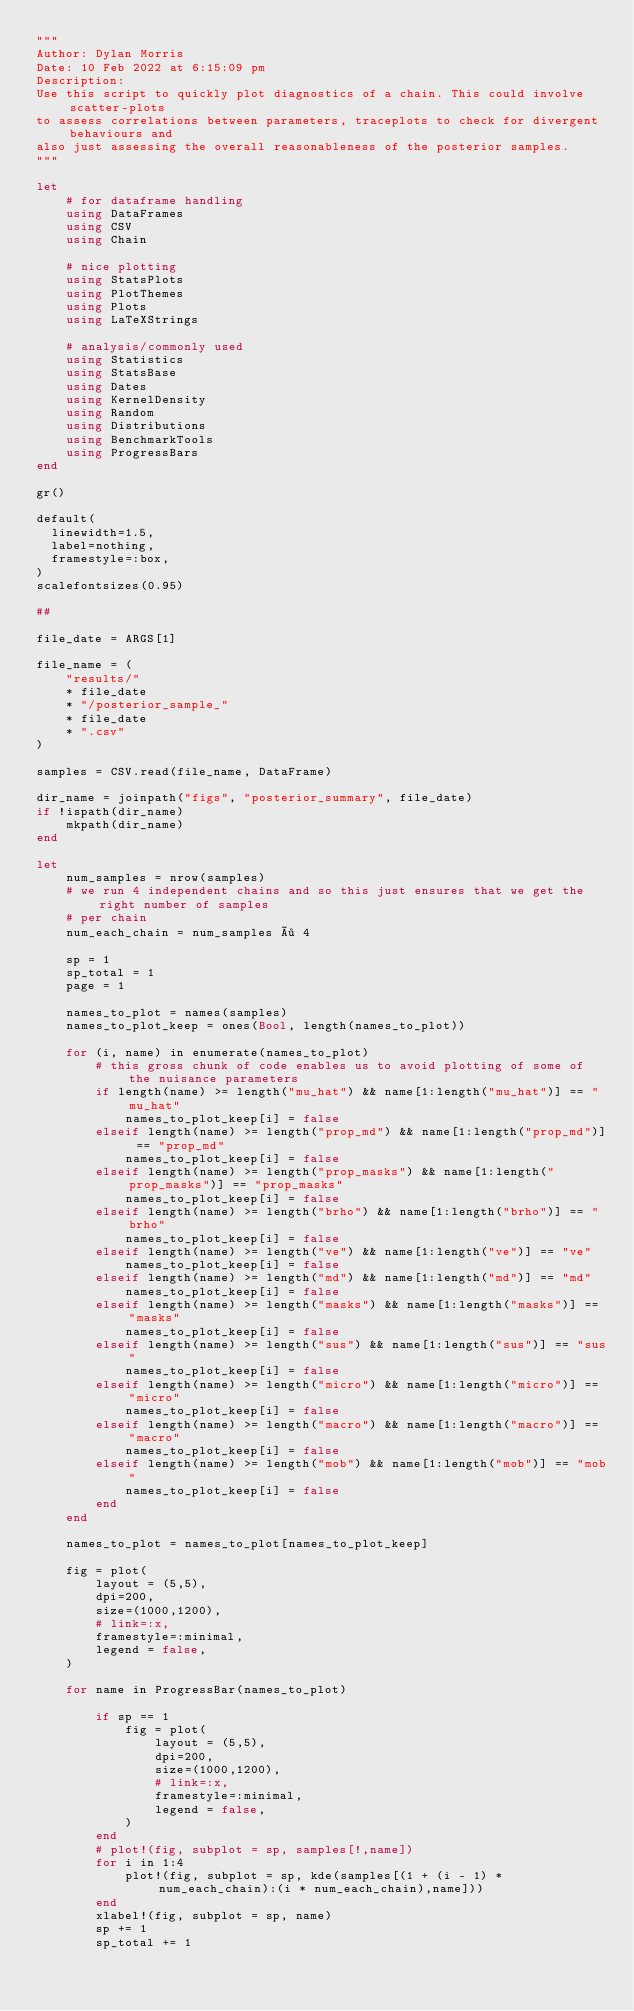Convert code to text. <code><loc_0><loc_0><loc_500><loc_500><_Julia_>"""
Author: Dylan Morris
Date: 10 Feb 2022 at 6:15:09 pm
Description: 
Use this script to quickly plot diagnostics of a chain. This could involve scatter-plots 
to assess correlations between parameters, traceplots to check for divergent behaviours and
also just assessing the overall reasonableness of the posterior samples. 
"""

let
    # for dataframe handling 
    using DataFrames
    using CSV
    using Chain

    # nice plotting 
    using StatsPlots
    using PlotThemes
    using Plots
    using LaTeXStrings

    # analysis/commonly used
    using Statistics
    using StatsBase 
    using Dates
    using KernelDensity
    using Random
    using Distributions
    using BenchmarkTools
    using ProgressBars
end

gr()

default(
	linewidth=1.5, 
	label=nothing, 
	framestyle=:box,
)
scalefontsizes(0.95)

##

file_date = ARGS[1]

file_name = (
    "results/"
    * file_date 
    * "/posterior_sample_"
    * file_date 
    * ".csv"
)

samples = CSV.read(file_name, DataFrame)

dir_name = joinpath("figs", "posterior_summary", file_date)
if !ispath(dir_name)
    mkpath(dir_name)
end

let
    num_samples = nrow(samples)
    # we run 4 independent chains and so this just ensures that we get the right number of samples 
    # per chain 
    num_each_chain = num_samples ÷ 4
    
    sp = 1
    sp_total = 1
    page = 1

    names_to_plot = names(samples)
    names_to_plot_keep = ones(Bool, length(names_to_plot))
    
    for (i, name) in enumerate(names_to_plot)
        # this gross chunk of code enables us to avoid plotting of some of the nuisance parameters
        if length(name) >= length("mu_hat") && name[1:length("mu_hat")] == "mu_hat" 
            names_to_plot_keep[i] = false
        elseif length(name) >= length("prop_md") && name[1:length("prop_md")] == "prop_md"
            names_to_plot_keep[i] = false
        elseif length(name) >= length("prop_masks") && name[1:length("prop_masks")] == "prop_masks"
            names_to_plot_keep[i] = false
        elseif length(name) >= length("brho") && name[1:length("brho")] == "brho"
            names_to_plot_keep[i] = false
        elseif length(name) >= length("ve") && name[1:length("ve")] == "ve"
            names_to_plot_keep[i] = false
        elseif length(name) >= length("md") && name[1:length("md")] == "md"
            names_to_plot_keep[i] = false
        elseif length(name) >= length("masks") && name[1:length("masks")] == "masks"
            names_to_plot_keep[i] = false
        elseif length(name) >= length("sus") && name[1:length("sus")] == "sus"
            names_to_plot_keep[i] = false
        elseif length(name) >= length("micro") && name[1:length("micro")] == "micro"
            names_to_plot_keep[i] = false
        elseif length(name) >= length("macro") && name[1:length("macro")] == "macro"
            names_to_plot_keep[i] = false
        elseif length(name) >= length("mob") && name[1:length("mob")] == "mob"
            names_to_plot_keep[i] = false
        end 
    end
    
    names_to_plot = names_to_plot[names_to_plot_keep]

    fig = plot(
        layout = (5,5),
        dpi=200, 
        size=(1000,1200), 
        # link=:x, 
        framestyle=:minimal, 
        legend = false,
    )

    for name in ProgressBar(names_to_plot)
        
        if sp == 1
            fig = plot(
                layout = (5,5),
                dpi=200, 
                size=(1000,1200), 
                # link=:x, 
                framestyle=:minimal, 
                legend = false,
            )
        end
        # plot!(fig, subplot = sp, samples[!,name])
        for i in 1:4
            plot!(fig, subplot = sp, kde(samples[(1 + (i - 1) * num_each_chain):(i * num_each_chain),name]))
        end
        xlabel!(fig, subplot = sp, name)
        sp += 1
        sp_total += 1</code> 